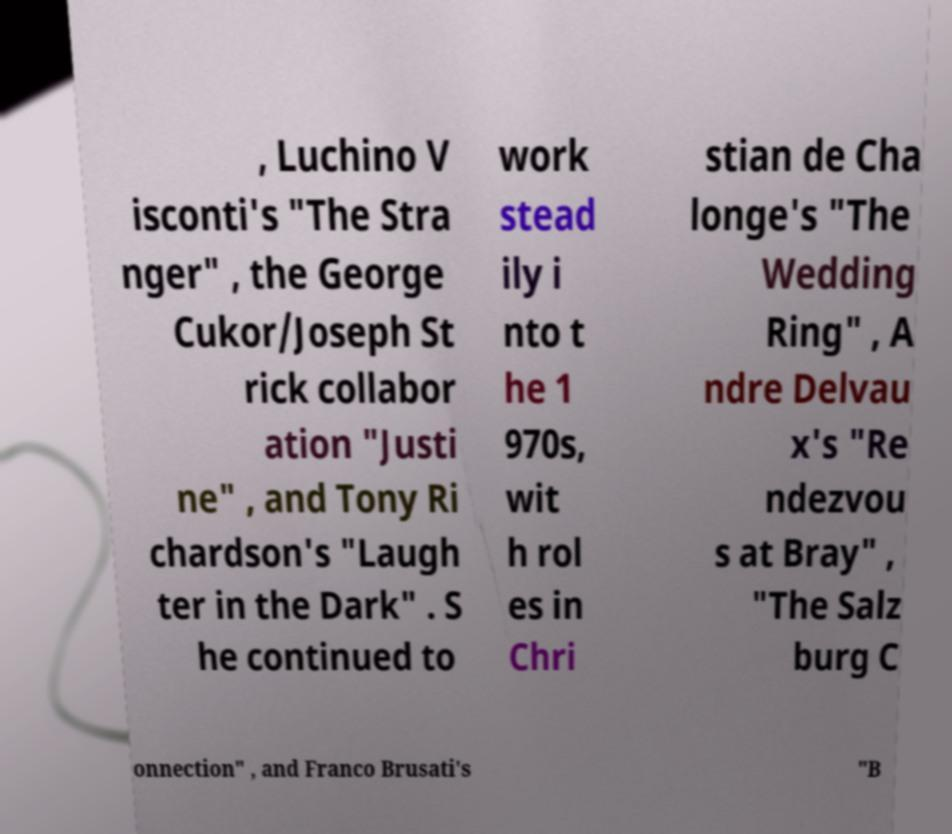Can you read and provide the text displayed in the image?This photo seems to have some interesting text. Can you extract and type it out for me? , Luchino V isconti's "The Stra nger" , the George Cukor/Joseph St rick collabor ation "Justi ne" , and Tony Ri chardson's "Laugh ter in the Dark" . S he continued to work stead ily i nto t he 1 970s, wit h rol es in Chri stian de Cha longe's "The Wedding Ring" , A ndre Delvau x's "Re ndezvou s at Bray" , "The Salz burg C onnection" , and Franco Brusati's "B 